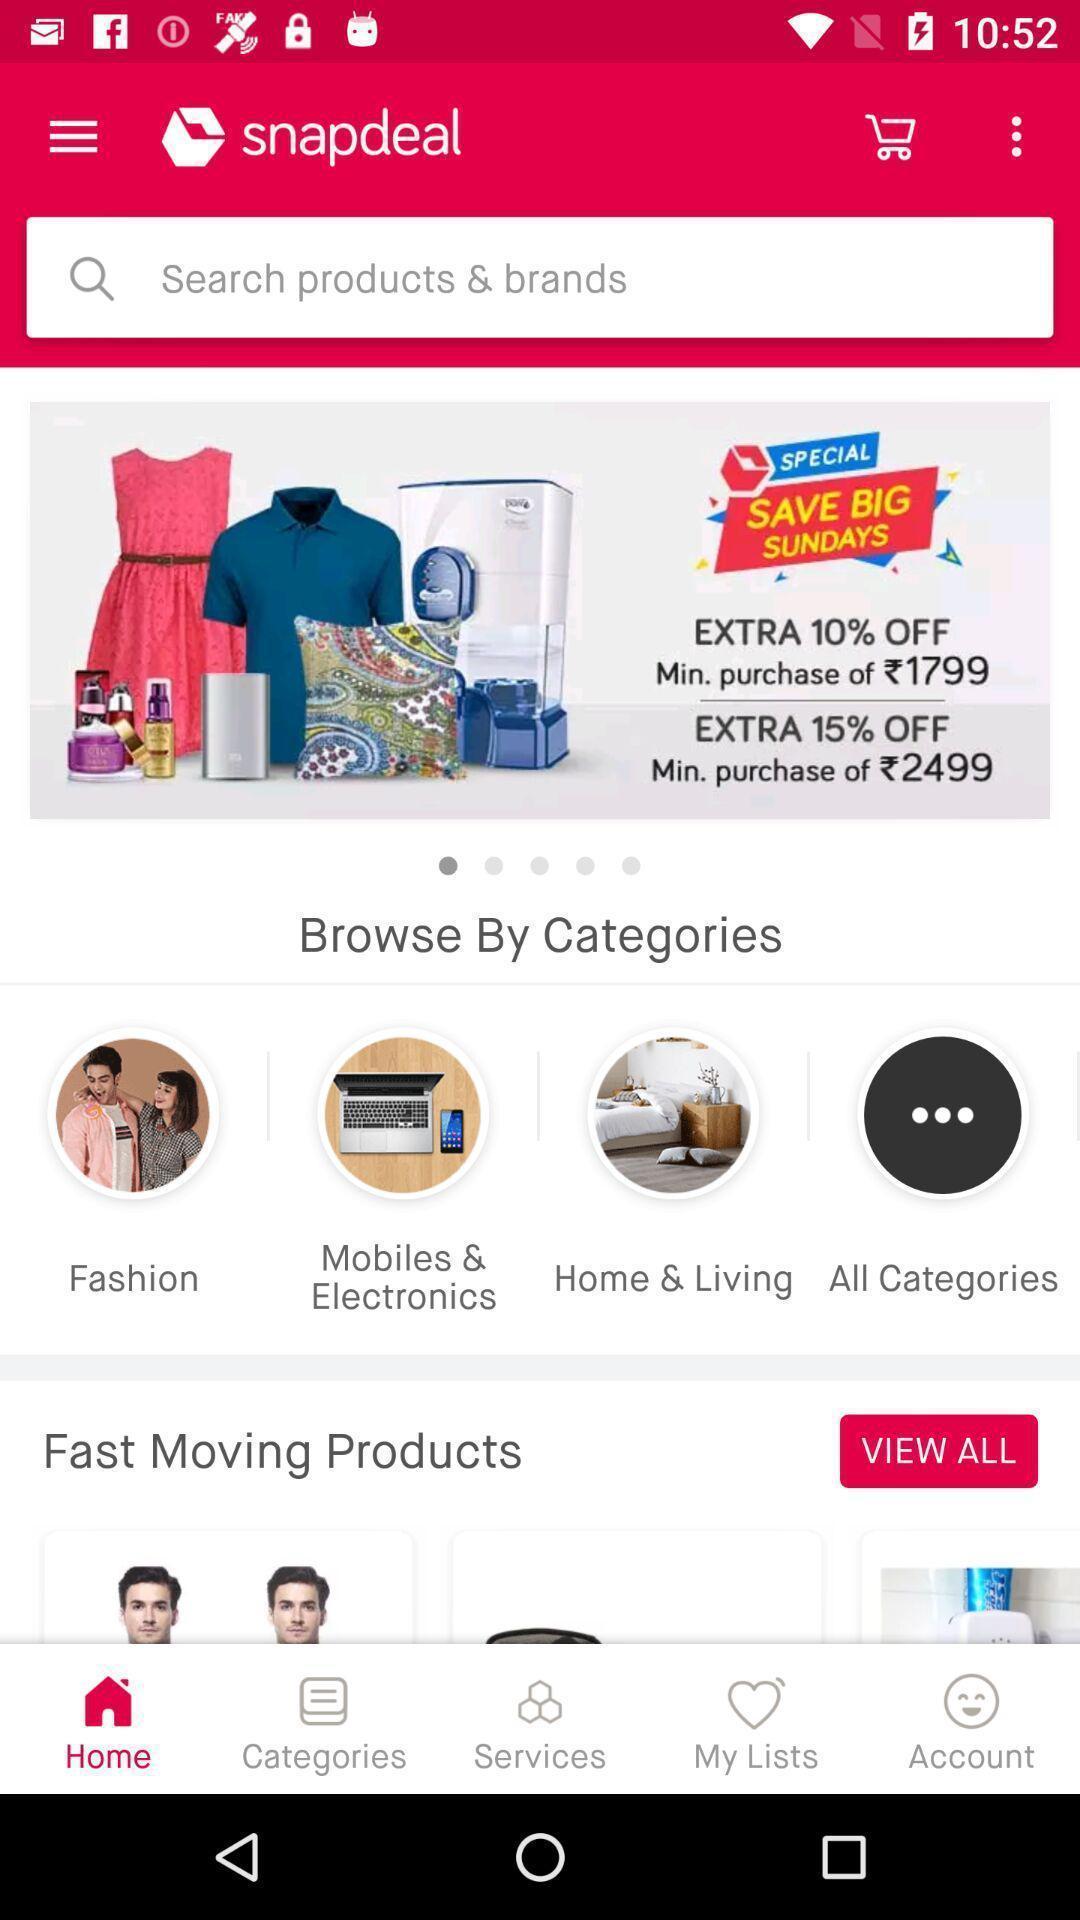Provide a textual representation of this image. Screen page of a shopping application. 